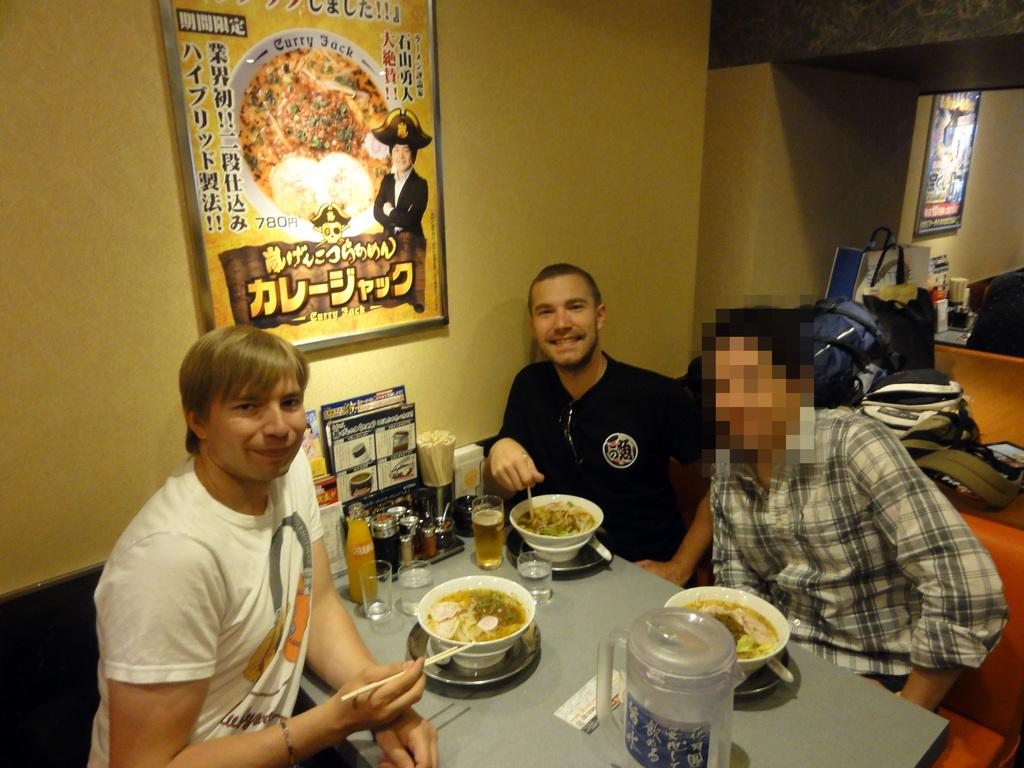How many people are in the image? There are three men in the image. What are the men doing in the image? The men are sitting at a table. What is on the table in the image? Food is being served on the table. What can be seen on the wall behind the men? There is a calendar hanging on the wall behind the men. What type of jam is being spread on the land in the image? There is no jam or land present in the image; it features three men sitting at a table with food being served. 